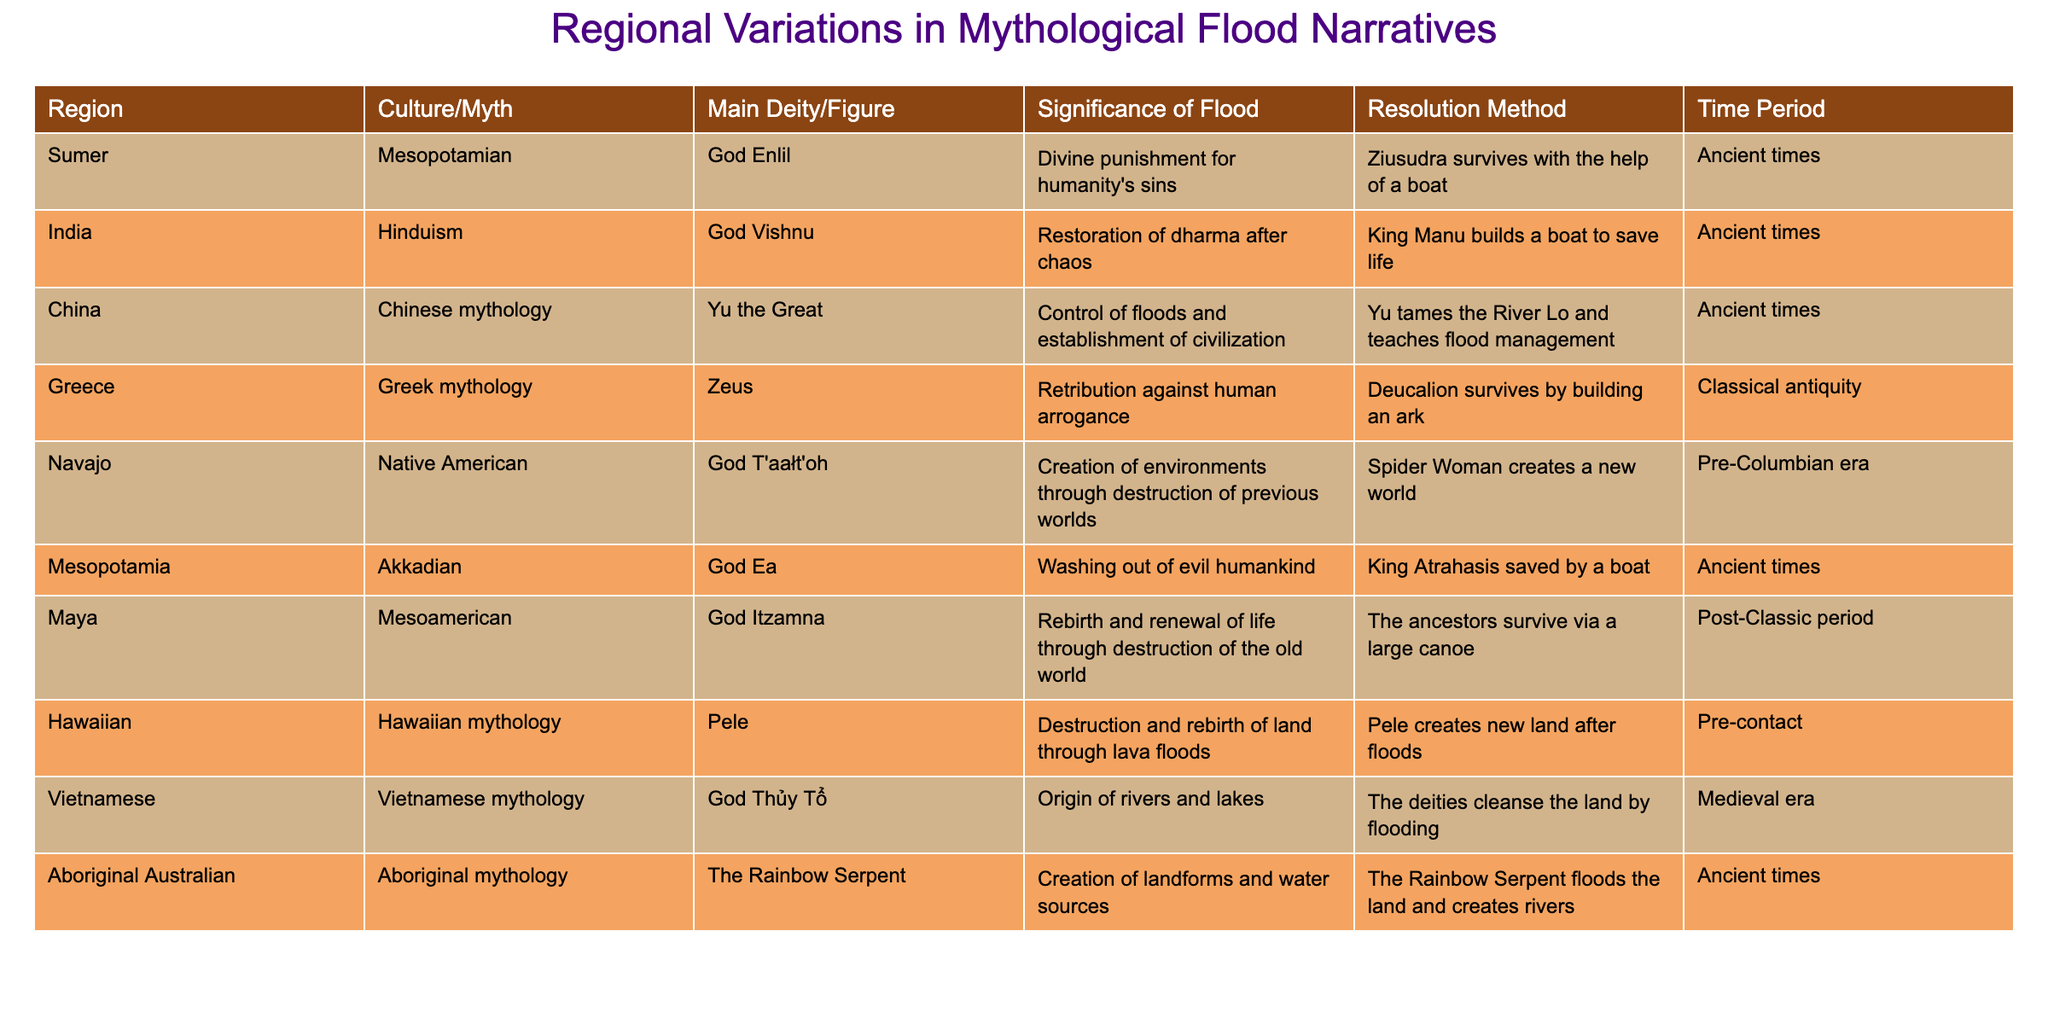What's the main deity in Greek mythology related to floods? The table identifies Zeus as the main deity associated with floods in Greek mythology.
Answer: Zeus Which culture's flood narrative involves the use of a boat for survival? The table lists several cultures where a boat was involved, specifically: Mesopotamian (Ziusudra), Hinduism (King Manu), Akkadian (King Atrahasis), and Greek mythology (Deucalion).
Answer: Mesopotamian, Hinduism, Akkadian, Greek mythology What is the significance of the flood in Indian mythology? The significance is the restoration of dharma after chaos, according to the information in the table.
Answer: Restoration of dharma after chaos Which narrative mentions the creation of new land after floods? In Hawaiian mythology, it is stated that Pele creates new land after the floods.
Answer: Hawaiian mythology How many cultures are listed in the table? The table contains data from 10 different cultures that have flood narratives.
Answer: 10 Is there a flood narrative from Vietnamese mythology? Yes, the table confirms that there is a narrative from Vietnamese mythology where God Thủy Tổ cleanses the land by flooding.
Answer: Yes What region's myth involves the flood being a divine punishment? The Sumerian myth, where the flood is a divine punishment for humanity's sins, is from the region of Sumer.
Answer: Sumer Does the table include a flood narrative that emphasizes environmental creation? Yes, the Navajo narrative includes the concept of creating environments through the destruction of previous worlds.
Answer: Yes Which cultures view the flood as a form of creation rather than destruction? The narratives from the Navajo and Aboriginal Australian cultures view the flood as a creation process, as they involve the creation of new worlds and landforms.
Answer: Navajo and Aboriginal Australian What resolution method is shared between the Mesopotamian and Akkadian narratives? Both narratives involve a character surviving a flood by using a boat as a resolution method.
Answer: Using a boat Which regions had their flood narratives developed during ancient times? The table shows that flood narratives from Sumer, India, China, Greek mythology, Akkadian, and Aboriginal Australian cultures were developed during ancient times.
Answer: Sumer, India, China, Greek mythology, Akkadian, Aboriginal Australian 